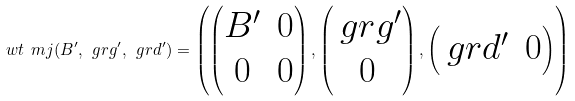Convert formula to latex. <formula><loc_0><loc_0><loc_500><loc_500>\ w t { \ m j } ( B ^ { \prime } , \ g r g ^ { \prime } , \ g r d ^ { \prime } ) = \left ( \begin{pmatrix} B ^ { \prime } & 0 \\ 0 & 0 \end{pmatrix} , \begin{pmatrix} \ g r g ^ { \prime } \\ 0 \end{pmatrix} , \begin{pmatrix} \ g r d ^ { \prime } & 0 \end{pmatrix} \right )</formula> 